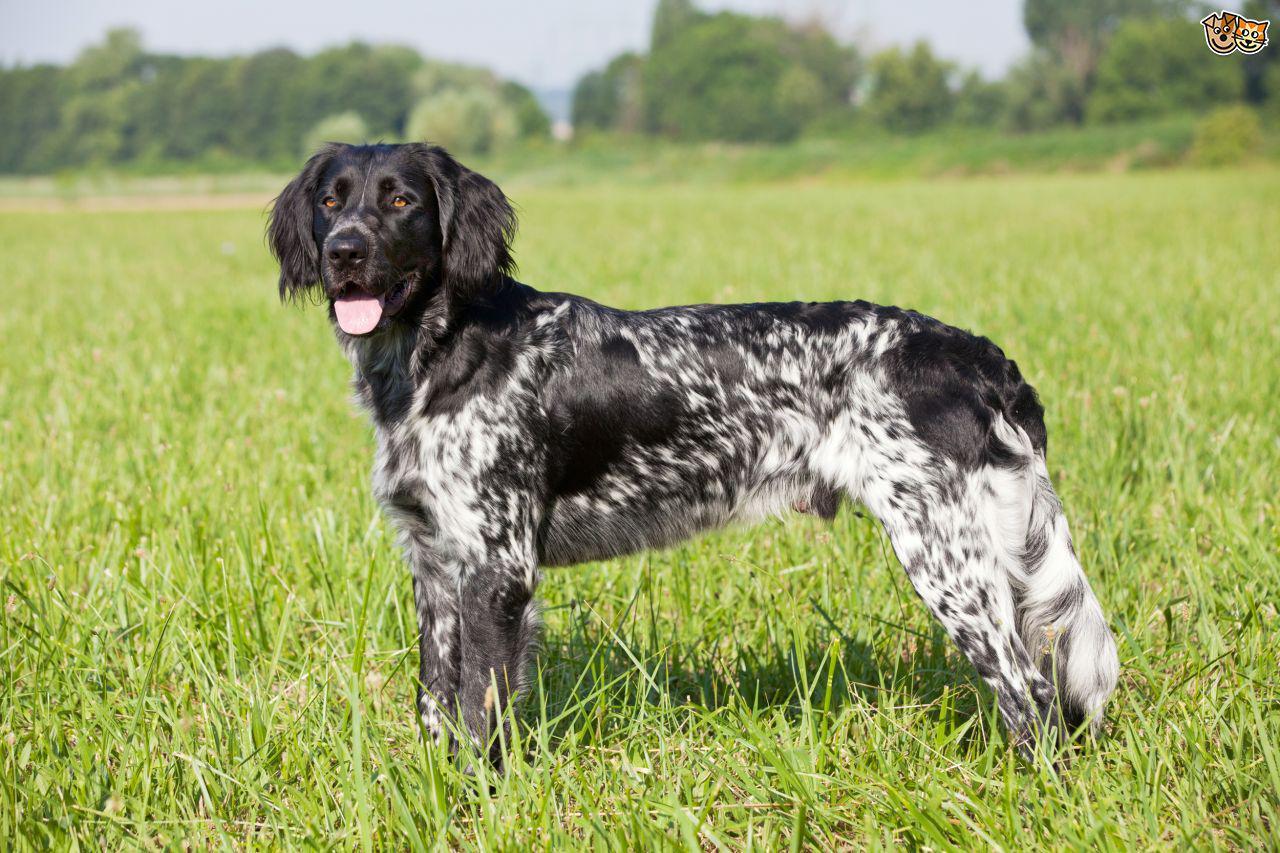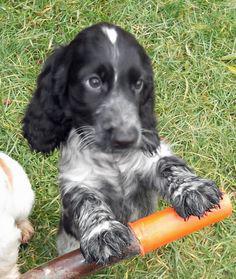The first image is the image on the left, the second image is the image on the right. For the images displayed, is the sentence "One dog is sitting with its tongue hanging out." factually correct? Answer yes or no. No. The first image is the image on the left, the second image is the image on the right. Evaluate the accuracy of this statement regarding the images: "The dog on the left has its tongue out.". Is it true? Answer yes or no. Yes. 